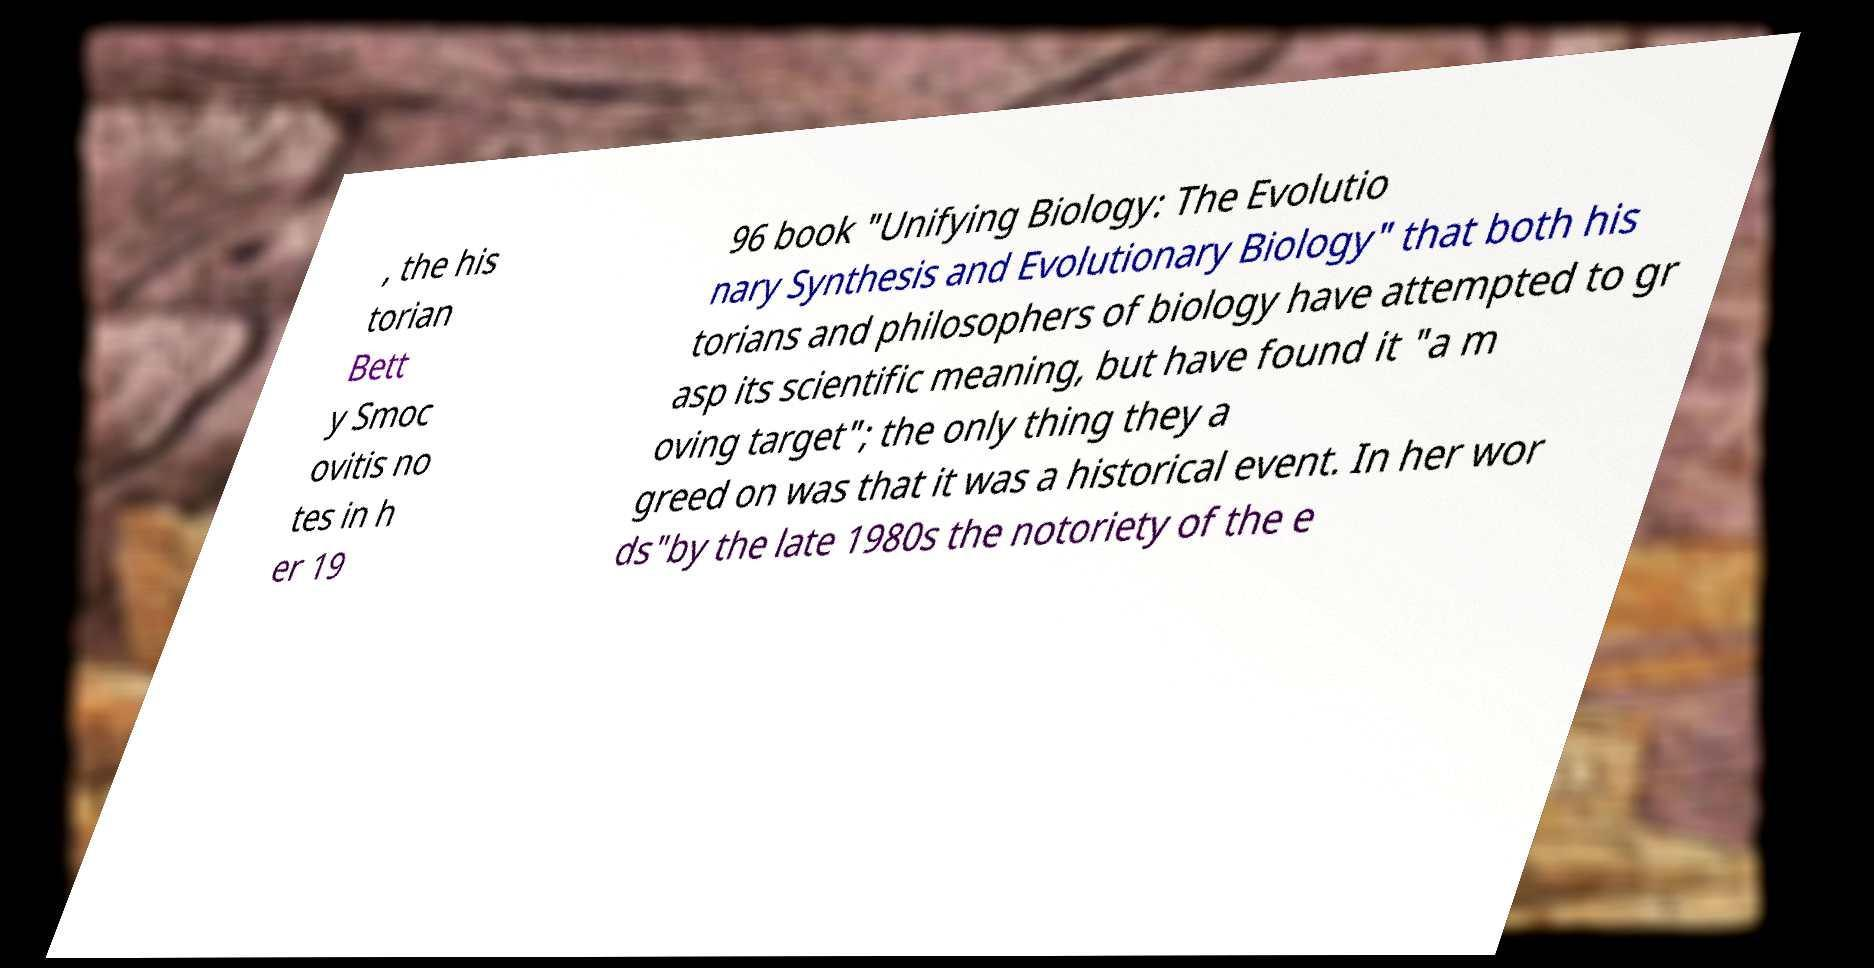Could you extract and type out the text from this image? , the his torian Bett y Smoc ovitis no tes in h er 19 96 book "Unifying Biology: The Evolutio nary Synthesis and Evolutionary Biology" that both his torians and philosophers of biology have attempted to gr asp its scientific meaning, but have found it "a m oving target"; the only thing they a greed on was that it was a historical event. In her wor ds"by the late 1980s the notoriety of the e 